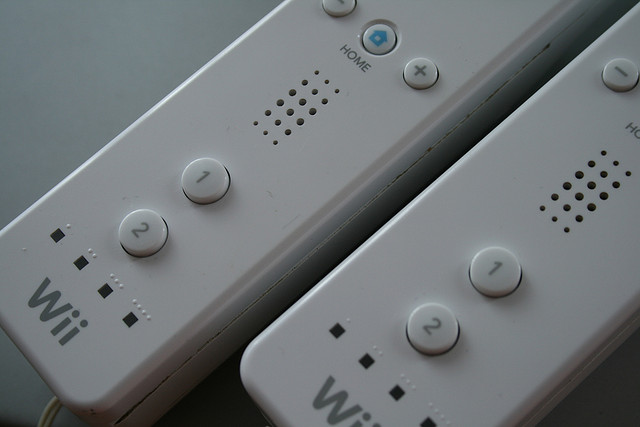Identify the text contained in this image. HOME Wii Wii 2 1 2 1 